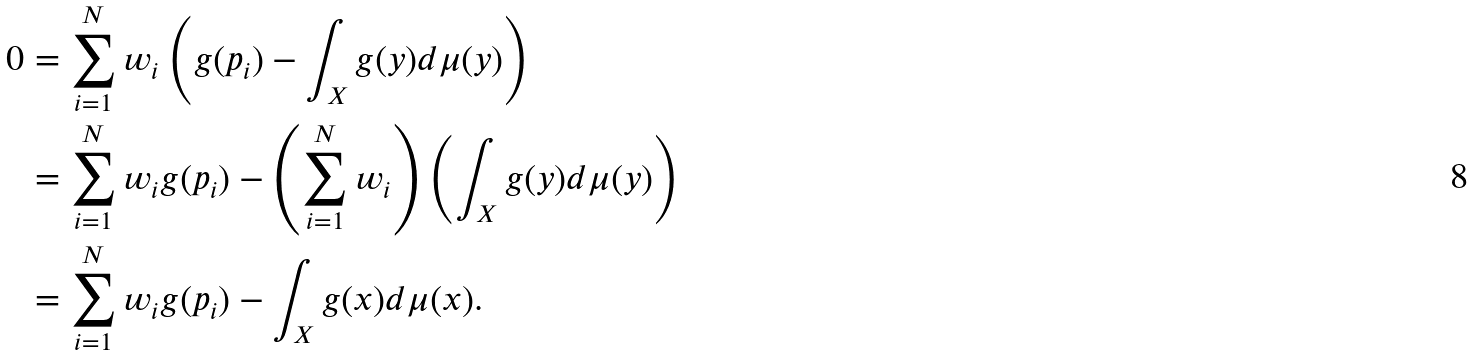<formula> <loc_0><loc_0><loc_500><loc_500>0 & = \sum _ { i = 1 } ^ { N } w _ { i } \left ( g ( p _ { i } ) - \int _ { X } g ( y ) d \mu ( y ) \right ) \\ & = \sum _ { i = 1 } ^ { N } w _ { i } g ( p _ { i } ) - \left ( \sum _ { i = 1 } ^ { N } w _ { i } \right ) \left ( \int _ { X } g ( y ) d \mu ( y ) \right ) \\ & = \sum _ { i = 1 } ^ { N } w _ { i } g ( p _ { i } ) - \int _ { X } g ( x ) d \mu ( x ) .</formula> 